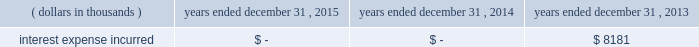Junior subordinated debt securities payable in accordance with the provisions of the junior subordinated debt securities which were issued on march 29 , 2004 , holdings elected to redeem the $ 329897 thousand of 6.2% ( 6.2 % ) junior subordinated debt securities outstanding on may 24 , 2013 .
As a result of the early redemption , the company incurred pre-tax expense of $ 7282 thousand related to the immediate amortization of the remaining capitalized issuance costs on the trust preferred securities .
Interest expense incurred in connection with these junior subordinated debt securities is as follows for the periods indicated: .
Holdings considered the mechanisms and obligations relating to the trust preferred securities , taken together , constituted a full and unconditional guarantee by holdings of capital trust ii 2019s payment obligations with respect to their trust preferred securities .
10 .
Reinsurance and trust agreements certain subsidiaries of group have established trust agreements , which effectively use the company 2019s investments as collateral , as security for assumed losses payable to certain non-affiliated ceding companies .
At december 31 , 2015 , the total amount on deposit in trust accounts was $ 454384 thousand .
On april 24 , 2014 , the company entered into two collateralized reinsurance agreements with kilimanjaro re limited ( 201ckilimanjaro 201d ) , a bermuda based special purpose reinsurer , to provide the company with catastrophe reinsurance coverage .
These agreements are multi-year reinsurance contracts which cover specified named storm and earthquake events .
The first agreement provides up to $ 250000 thousand of reinsurance coverage from named storms in specified states of the southeastern united states .
The second agreement provides up to $ 200000 thousand of reinsurance coverage from named storms in specified states of the southeast , mid-atlantic and northeast regions of the united states and puerto rico as well as reinsurance coverage from earthquakes in specified states of the southeast , mid-atlantic , northeast and west regions of the united states , puerto rico and british columbia .
On november 18 , 2014 , the company entered into a collateralized reinsurance agreement with kilimanjaro re to provide the company with catastrophe reinsurance coverage .
This agreement is a multi-year reinsurance contract which covers specified earthquake events .
The agreement provides up to $ 500000 thousand of reinsurance coverage from earthquakes in the united states , puerto rico and canada .
On december 1 , 2015 the company entered into two collateralized reinsurance agreements with kilimanjaro re to provide the company with catastrophe reinsurance coverage .
These agreements are multi-year reinsurance contracts which cover named storm and earthquake events .
The first agreement provides up to $ 300000 thousand of reinsurance coverage from named storms and earthquakes in the united states , puerto rico and canada .
The second agreement provides up to $ 325000 thousand of reinsurance coverage from named storms and earthquakes in the united states , puerto rico and canada .
Kilimanjaro has financed the various property catastrophe reinsurance coverage by issuing catastrophe bonds to unrelated , external investors .
On april 24 , 2014 , kilimanjaro issued $ 450000 thousand of notes ( 201cseries 2014-1 notes 201d ) .
On november 18 , 2014 , kilimanjaro issued $ 500000 thousand of notes ( 201cseries 2014-2 notes 201d ) .
On december 1 , 2015 , kilimanjaro issued $ 625000 thousand of notes ( 201cseries 2015-1 notes ) .
The proceeds from the issuance of the series 2014-1 notes , the series 2014-2 notes and the series 2015-1 notes are held in reinsurance trust throughout the duration of the applicable reinsurance agreements and invested solely in us government money market funds with a rating of at least 201caaam 201d by standard & poor 2019s. .
What is the yearly interest incurred by the redeemed amount of junior subordinated debt , in thousands? 
Computations: (329897 * 6.2%)
Answer: 20453.614. 